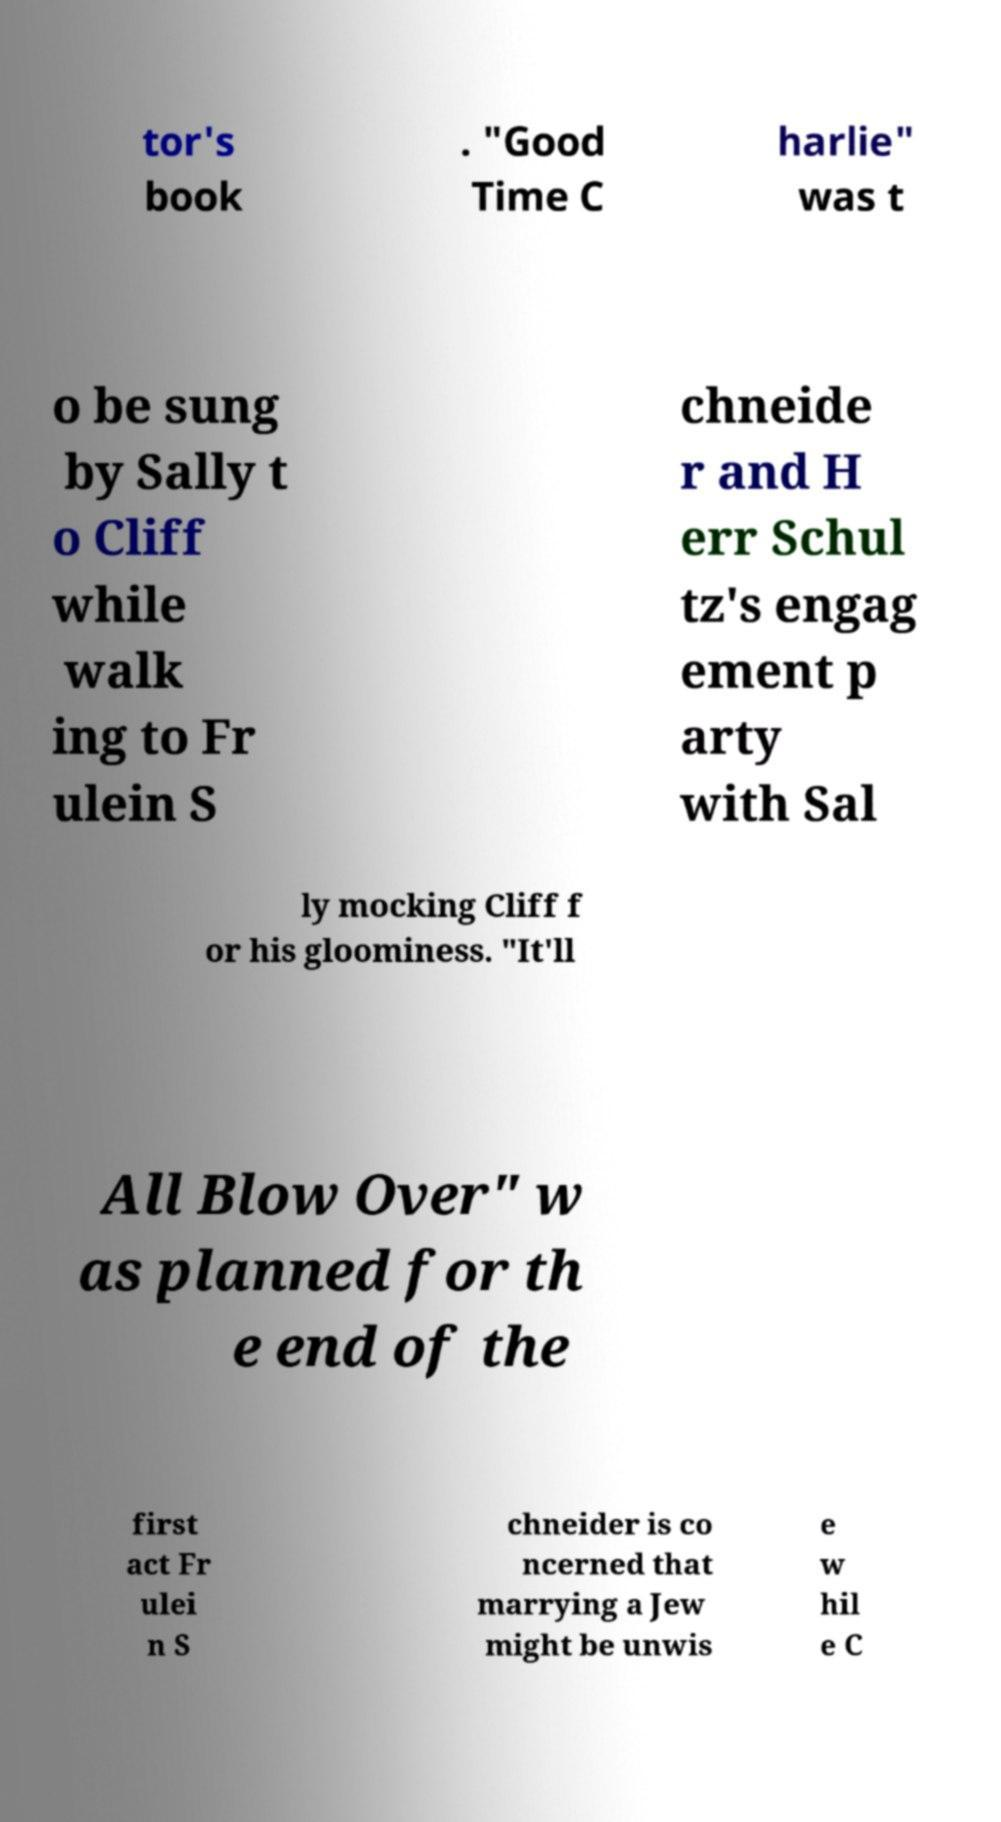I need the written content from this picture converted into text. Can you do that? tor's book . "Good Time C harlie" was t o be sung by Sally t o Cliff while walk ing to Fr ulein S chneide r and H err Schul tz's engag ement p arty with Sal ly mocking Cliff f or his gloominess. "It'll All Blow Over" w as planned for th e end of the first act Fr ulei n S chneider is co ncerned that marrying a Jew might be unwis e w hil e C 